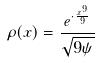<formula> <loc_0><loc_0><loc_500><loc_500>\rho ( x ) = \frac { e ^ { \cdot \frac { x ^ { 9 } } { 9 } } } { \sqrt { 9 \psi } }</formula> 